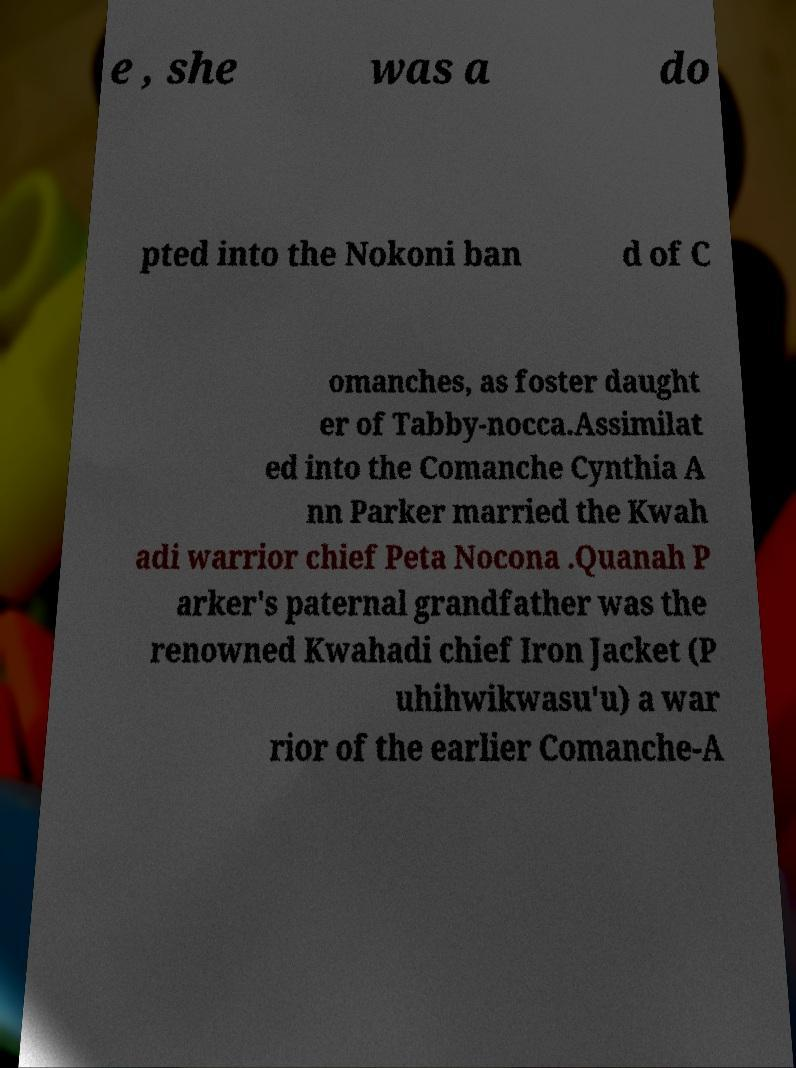Can you read and provide the text displayed in the image?This photo seems to have some interesting text. Can you extract and type it out for me? e , she was a do pted into the Nokoni ban d of C omanches, as foster daught er of Tabby-nocca.Assimilat ed into the Comanche Cynthia A nn Parker married the Kwah adi warrior chief Peta Nocona .Quanah P arker's paternal grandfather was the renowned Kwahadi chief Iron Jacket (P uhihwikwasu'u) a war rior of the earlier Comanche-A 